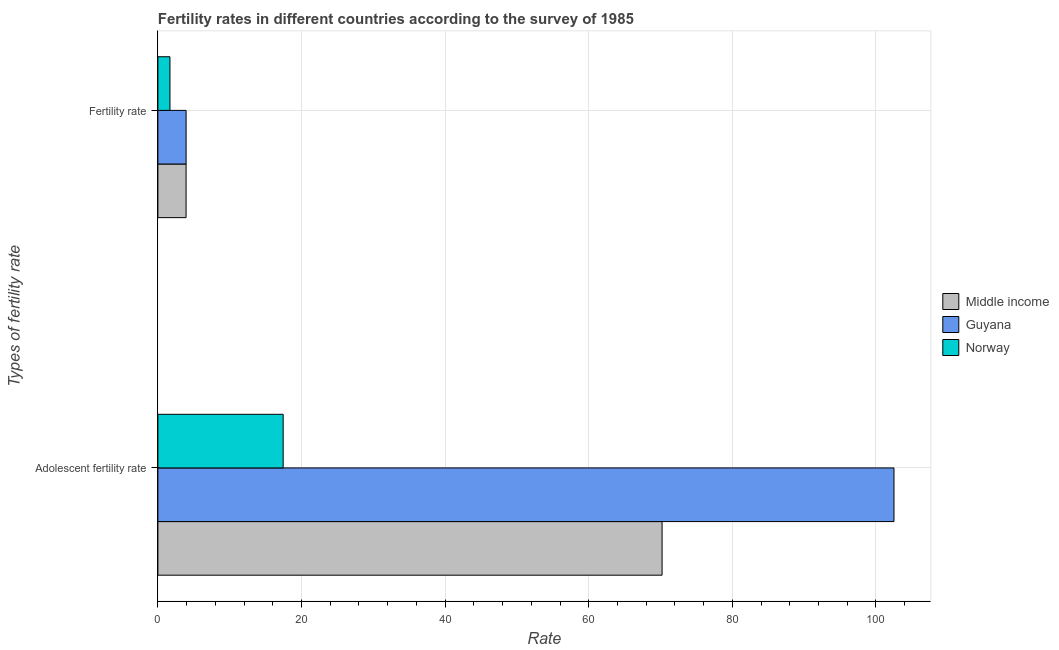How many groups of bars are there?
Your answer should be very brief. 2. How many bars are there on the 2nd tick from the top?
Keep it short and to the point. 3. What is the label of the 1st group of bars from the top?
Provide a succinct answer. Fertility rate. What is the fertility rate in Middle income?
Keep it short and to the point. 3.93. Across all countries, what is the maximum adolescent fertility rate?
Give a very brief answer. 102.51. Across all countries, what is the minimum adolescent fertility rate?
Keep it short and to the point. 17.45. In which country was the fertility rate maximum?
Offer a terse response. Guyana. What is the total adolescent fertility rate in the graph?
Provide a short and direct response. 190.18. What is the difference between the adolescent fertility rate in Guyana and that in Norway?
Keep it short and to the point. 85.07. What is the difference between the fertility rate in Guyana and the adolescent fertility rate in Middle income?
Offer a terse response. -66.29. What is the average fertility rate per country?
Ensure brevity in your answer.  3.18. What is the difference between the fertility rate and adolescent fertility rate in Guyana?
Provide a succinct answer. -98.58. In how many countries, is the adolescent fertility rate greater than 84 ?
Provide a succinct answer. 1. What is the ratio of the adolescent fertility rate in Guyana to that in Norway?
Give a very brief answer. 5.88. Is the fertility rate in Middle income less than that in Guyana?
Ensure brevity in your answer.  Yes. What does the 3rd bar from the top in Fertility rate represents?
Your response must be concise. Middle income. What does the 1st bar from the bottom in Adolescent fertility rate represents?
Give a very brief answer. Middle income. Are all the bars in the graph horizontal?
Give a very brief answer. Yes. Are the values on the major ticks of X-axis written in scientific E-notation?
Provide a short and direct response. No. What is the title of the graph?
Provide a short and direct response. Fertility rates in different countries according to the survey of 1985. What is the label or title of the X-axis?
Offer a very short reply. Rate. What is the label or title of the Y-axis?
Offer a very short reply. Types of fertility rate. What is the Rate of Middle income in Adolescent fertility rate?
Provide a succinct answer. 70.22. What is the Rate in Guyana in Adolescent fertility rate?
Your response must be concise. 102.51. What is the Rate in Norway in Adolescent fertility rate?
Keep it short and to the point. 17.45. What is the Rate of Middle income in Fertility rate?
Provide a succinct answer. 3.93. What is the Rate of Guyana in Fertility rate?
Provide a short and direct response. 3.93. What is the Rate in Norway in Fertility rate?
Ensure brevity in your answer.  1.68. Across all Types of fertility rate, what is the maximum Rate of Middle income?
Offer a terse response. 70.22. Across all Types of fertility rate, what is the maximum Rate in Guyana?
Your answer should be very brief. 102.51. Across all Types of fertility rate, what is the maximum Rate in Norway?
Keep it short and to the point. 17.45. Across all Types of fertility rate, what is the minimum Rate in Middle income?
Your answer should be compact. 3.93. Across all Types of fertility rate, what is the minimum Rate of Guyana?
Keep it short and to the point. 3.93. Across all Types of fertility rate, what is the minimum Rate in Norway?
Your answer should be compact. 1.68. What is the total Rate in Middle income in the graph?
Offer a terse response. 74.14. What is the total Rate of Guyana in the graph?
Provide a short and direct response. 106.44. What is the total Rate in Norway in the graph?
Provide a succinct answer. 19.13. What is the difference between the Rate of Middle income in Adolescent fertility rate and that in Fertility rate?
Give a very brief answer. 66.29. What is the difference between the Rate in Guyana in Adolescent fertility rate and that in Fertility rate?
Give a very brief answer. 98.58. What is the difference between the Rate in Norway in Adolescent fertility rate and that in Fertility rate?
Your answer should be compact. 15.77. What is the difference between the Rate of Middle income in Adolescent fertility rate and the Rate of Guyana in Fertility rate?
Provide a short and direct response. 66.29. What is the difference between the Rate in Middle income in Adolescent fertility rate and the Rate in Norway in Fertility rate?
Your answer should be very brief. 68.54. What is the difference between the Rate of Guyana in Adolescent fertility rate and the Rate of Norway in Fertility rate?
Your response must be concise. 100.83. What is the average Rate of Middle income per Types of fertility rate?
Ensure brevity in your answer.  37.07. What is the average Rate of Guyana per Types of fertility rate?
Provide a short and direct response. 53.22. What is the average Rate in Norway per Types of fertility rate?
Your response must be concise. 9.56. What is the difference between the Rate of Middle income and Rate of Guyana in Adolescent fertility rate?
Your response must be concise. -32.3. What is the difference between the Rate in Middle income and Rate in Norway in Adolescent fertility rate?
Offer a terse response. 52.77. What is the difference between the Rate in Guyana and Rate in Norway in Adolescent fertility rate?
Give a very brief answer. 85.07. What is the difference between the Rate of Middle income and Rate of Guyana in Fertility rate?
Keep it short and to the point. -0.01. What is the difference between the Rate of Middle income and Rate of Norway in Fertility rate?
Offer a very short reply. 2.25. What is the difference between the Rate of Guyana and Rate of Norway in Fertility rate?
Keep it short and to the point. 2.25. What is the ratio of the Rate in Middle income in Adolescent fertility rate to that in Fertility rate?
Keep it short and to the point. 17.89. What is the ratio of the Rate in Guyana in Adolescent fertility rate to that in Fertility rate?
Offer a very short reply. 26.08. What is the ratio of the Rate of Norway in Adolescent fertility rate to that in Fertility rate?
Give a very brief answer. 10.39. What is the difference between the highest and the second highest Rate of Middle income?
Ensure brevity in your answer.  66.29. What is the difference between the highest and the second highest Rate in Guyana?
Provide a succinct answer. 98.58. What is the difference between the highest and the second highest Rate of Norway?
Keep it short and to the point. 15.77. What is the difference between the highest and the lowest Rate of Middle income?
Keep it short and to the point. 66.29. What is the difference between the highest and the lowest Rate in Guyana?
Your response must be concise. 98.58. What is the difference between the highest and the lowest Rate in Norway?
Provide a short and direct response. 15.77. 